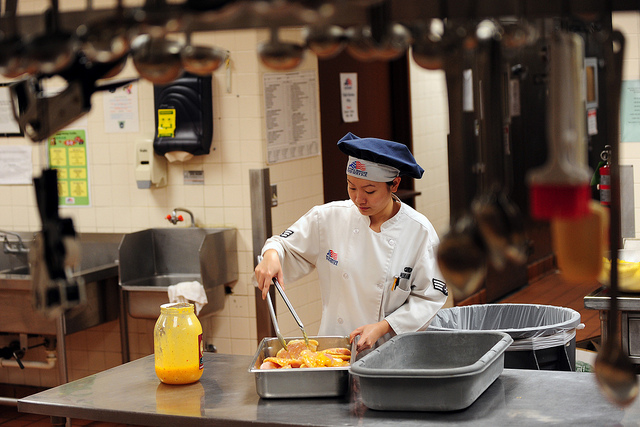What might the chef be thinking about while preparing this dish? The chef might be deeply focused on the task at hand, ensuring that each step is performed with precision to create a perfect dish. She could be contemplating the balance of flavors, the presentation of the final dish, and how the meal will be received by those who will enjoy it. Additionally, she might be thinking ahead, planning the next stage of cooking or organizing her workspace for efficiency. There may also be a sense of pride and satisfaction in her work, knowing that her culinary skills will bring pleasure and nourishment to others. 